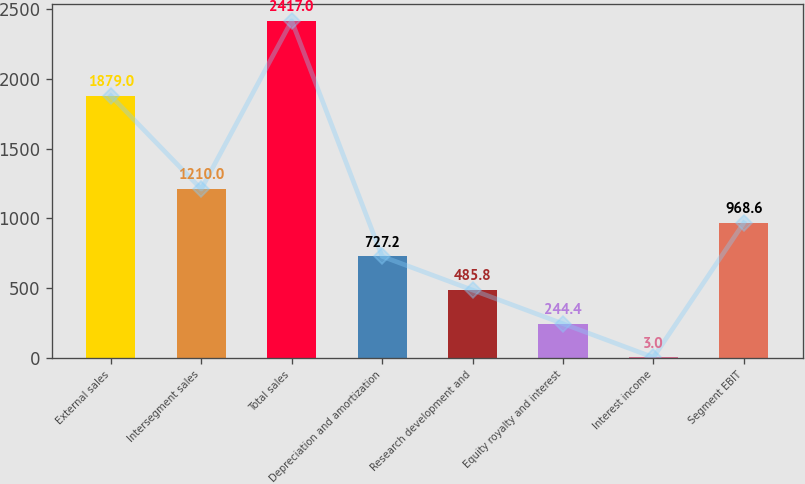Convert chart to OTSL. <chart><loc_0><loc_0><loc_500><loc_500><bar_chart><fcel>External sales<fcel>Intersegment sales<fcel>Total sales<fcel>Depreciation and amortization<fcel>Research development and<fcel>Equity royalty and interest<fcel>Interest income<fcel>Segment EBIT<nl><fcel>1879<fcel>1210<fcel>2417<fcel>727.2<fcel>485.8<fcel>244.4<fcel>3<fcel>968.6<nl></chart> 